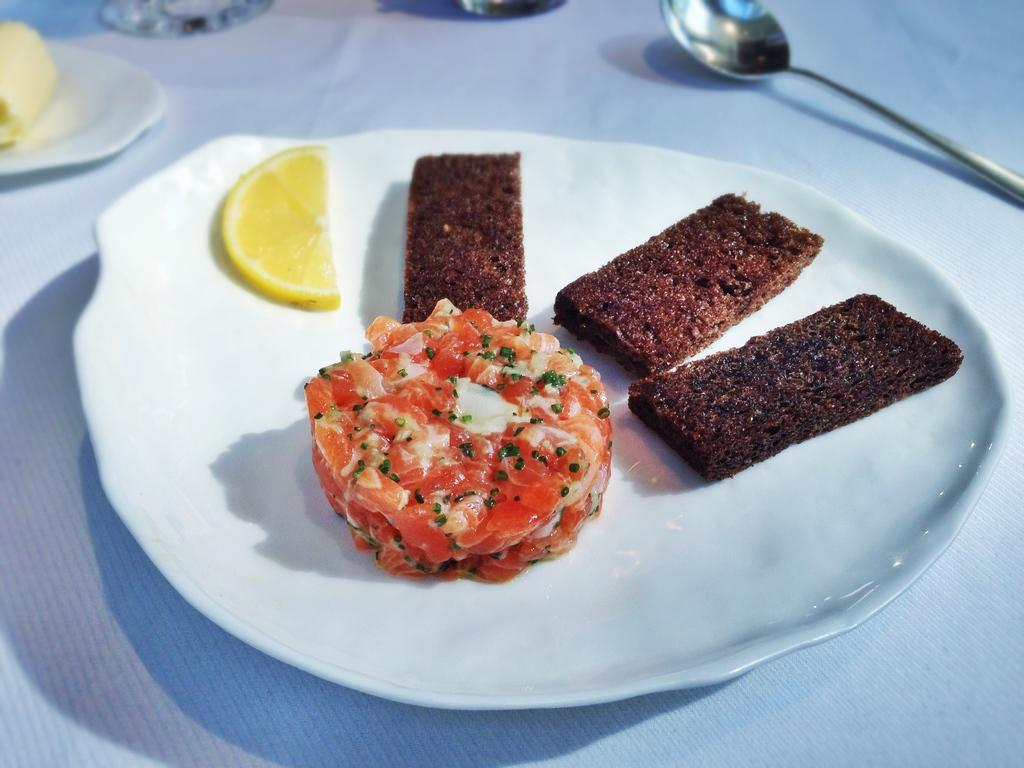What is on the plate that is visible in the image? There are food items on a plate in the image. What utensil is located beside the plate in the image? There is a spoon beside the plate in the image. What can be seen on the table in the image? There are glasses on the table in the image. What is the chance of the food items on the plate committing a crime in the image? There is no indication of any crime or criminal activity in the image, and the food items are inanimate objects, so they cannot commit crimes. 